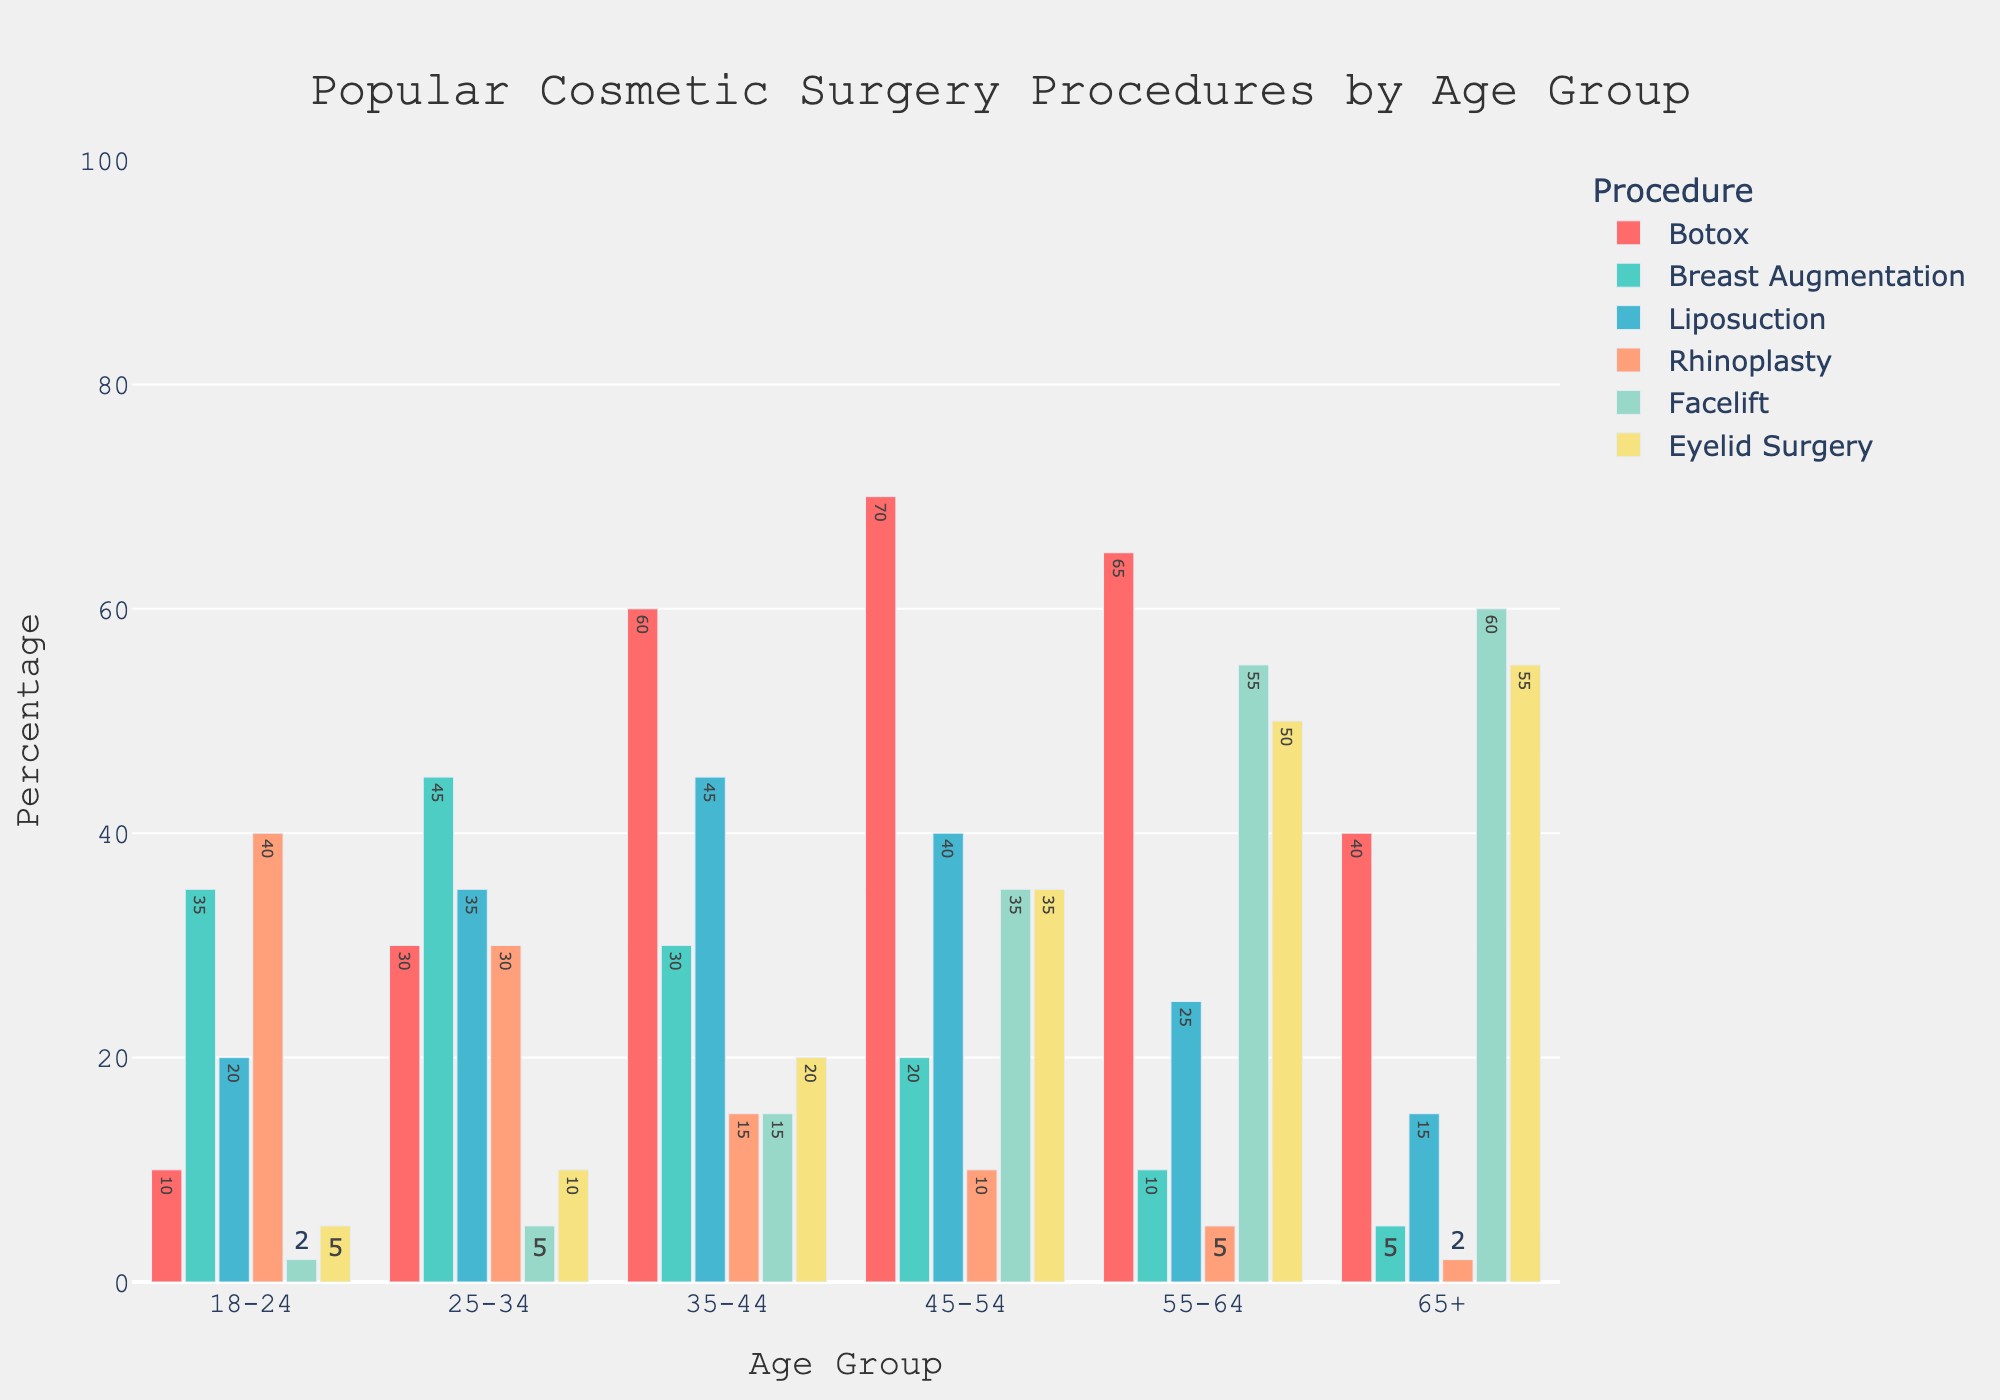What is the most popular cosmetic surgery procedure for the age group 18-24? To find this, look at the highest bar within the "18-24" age group across all procedures. The highest bar is for Rhinoplasty with a value of 40.
Answer: Rhinoplasty Which age group has the highest percentage of individuals undergoing Botox? To determine this, examine all bars corresponding to Botox across all age groups. The highest bar is in the "45-54" age group with a value of 70.
Answer: 45-54 What is the total percentage of individuals undergoing Eyelid Surgery for all age groups combined? Sum the Eyelid Surgery percentages across all age groups: 5 + 10 + 20 + 35 + 50 + 55 = 175.
Answer: 175 Compare the percentage of individuals undergoing Breast Augmentation for the age group 25-34 to Liposuction for the age group 35-44. Which is higher? Refer to the bars for Breast Augmentation at 25-34 and Liposuction at 35-44. Breast Augmentation (45) vs Liposuction (45). Since both values are equal, neither is higher.
Answer: Equal Which age group shows the least interest in Facelift procedures? Identify the smallest bar within the Facelift category across all age groups. The shortest bar is in the "18-24" age group with a value of 2.
Answer: 18-24 What's the difference in the number of people undergoing Rhinoplasty between the age groups 18-24 and 65+? Find the heights of the Rhinoplasty bars for the 18-24 (40) and 65+ (2) age groups. The difference is 40 - 2 = 38.
Answer: 38 Which procedure and age group combination shows both the highest and lowest percentages overall? The highest bar across the entire chart corresponds to Eyelid Surgery for 65+ with 55%. The lowest bar corresponds to Rhinoplasty for 65+ with 2%.
Answer: Eyelid Surgery for 65+ (highest) and Rhinoplasty for 65+ (lowest) What's the average percentage of people undergoing Liposuction across all age groups? Calculate the mean of the Liposuction percentages: (20 + 35 + 45 + 40 + 25 + 15) / 6 = 180 / 6 = 30%.
Answer: 30% How does the percentage of people undergoing Botox in the age group 45-54 compare to the overall average across all age groups? Calculate the average across all age groups: (10 + 30 + 60 + 70 + 65 + 40) / 6 = 275 / 6 ≈ 45.83%. Compare this with the Botox percentage for 45-54 (70). 70 is greater than the average 45.83%.
Answer: Greater Identify the trends in popularity for Facelift procedures as the age group increases. Observe the bars for Facelift across increasing age groups: 2, 5, 15, 35, 55, 60. The trend shows a steady increase in popularity as age increases.
Answer: Increasing 